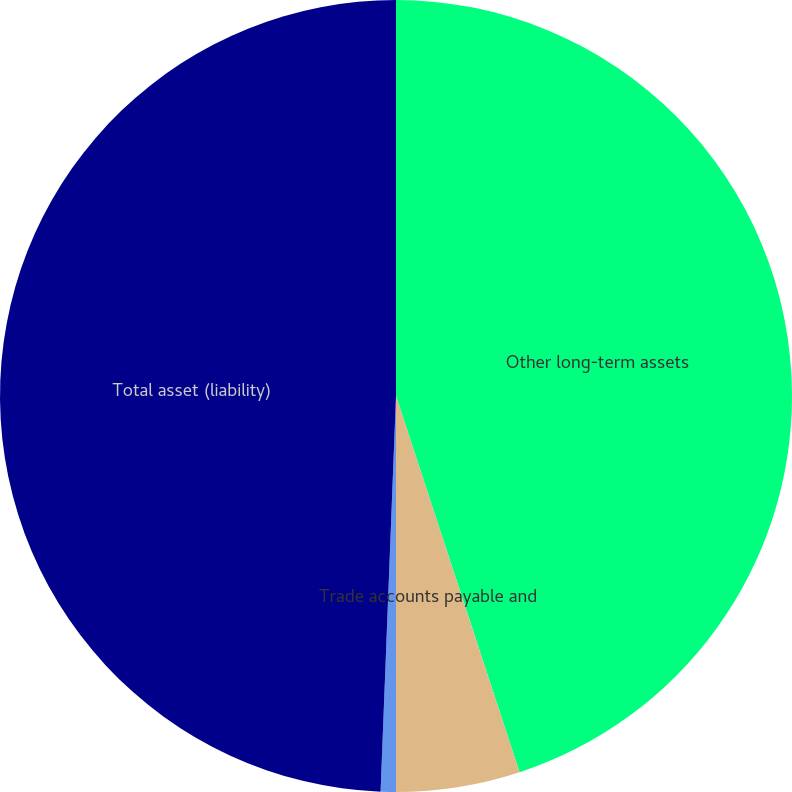<chart> <loc_0><loc_0><loc_500><loc_500><pie_chart><fcel>Other long-term assets<fcel>Trade accounts payable and<fcel>Long-term liabilities<fcel>Total asset (liability)<nl><fcel>44.95%<fcel>5.05%<fcel>0.62%<fcel>49.38%<nl></chart> 